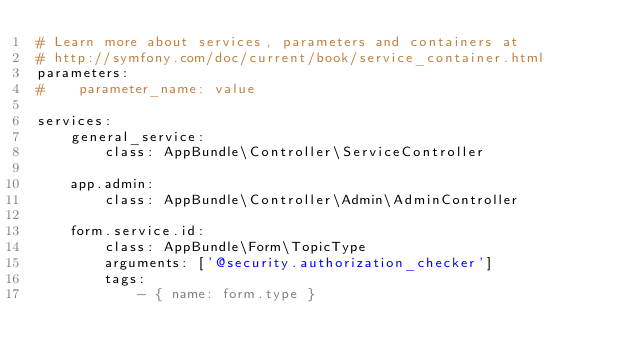<code> <loc_0><loc_0><loc_500><loc_500><_YAML_># Learn more about services, parameters and containers at
# http://symfony.com/doc/current/book/service_container.html
parameters:
#    parameter_name: value

services:
    general_service:
        class: AppBundle\Controller\ServiceController

    app.admin:
        class: AppBundle\Controller\Admin\AdminController

    form.service.id:
        class: AppBundle\Form\TopicType
        arguments: ['@security.authorization_checker']
        tags:
            - { name: form.type }



</code> 